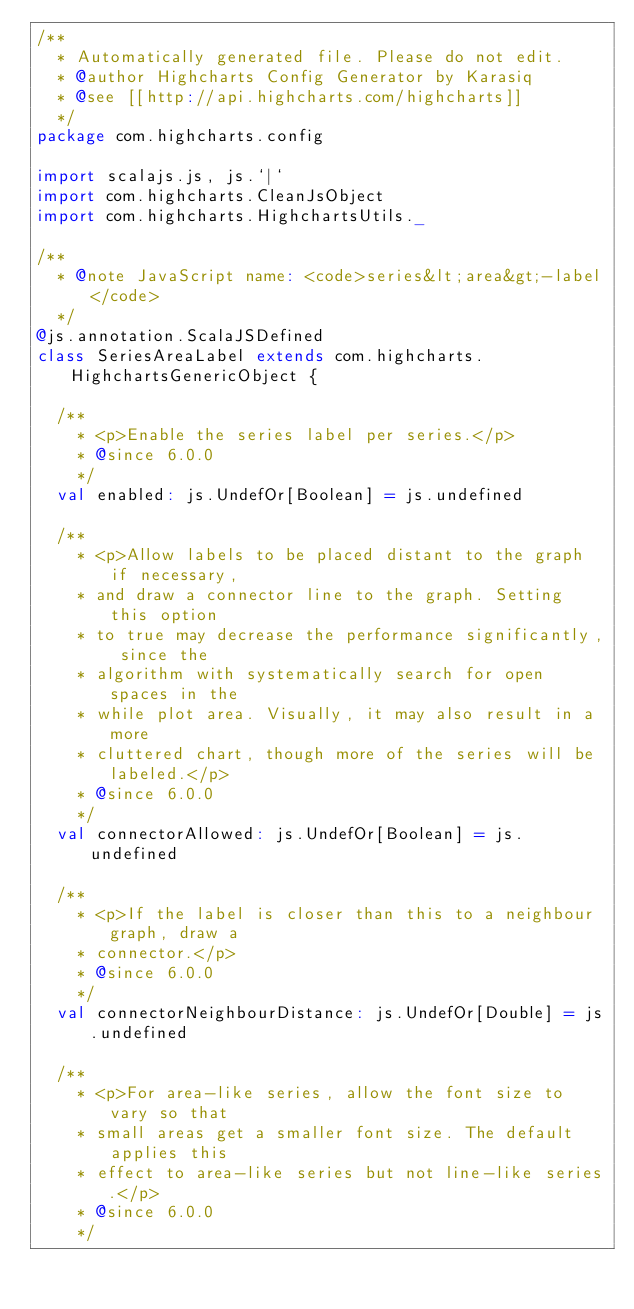Convert code to text. <code><loc_0><loc_0><loc_500><loc_500><_Scala_>/**
  * Automatically generated file. Please do not edit.
  * @author Highcharts Config Generator by Karasiq
  * @see [[http://api.highcharts.com/highcharts]]
  */
package com.highcharts.config

import scalajs.js, js.`|`
import com.highcharts.CleanJsObject
import com.highcharts.HighchartsUtils._

/**
  * @note JavaScript name: <code>series&lt;area&gt;-label</code>
  */
@js.annotation.ScalaJSDefined
class SeriesAreaLabel extends com.highcharts.HighchartsGenericObject {

  /**
    * <p>Enable the series label per series.</p>
    * @since 6.0.0
    */
  val enabled: js.UndefOr[Boolean] = js.undefined

  /**
    * <p>Allow labels to be placed distant to the graph if necessary,
    * and draw a connector line to the graph. Setting this option
    * to true may decrease the performance significantly, since the
    * algorithm with systematically search for open spaces in the
    * while plot area. Visually, it may also result in a more
    * cluttered chart, though more of the series will be labeled.</p>
    * @since 6.0.0
    */
  val connectorAllowed: js.UndefOr[Boolean] = js.undefined

  /**
    * <p>If the label is closer than this to a neighbour graph, draw a
    * connector.</p>
    * @since 6.0.0
    */
  val connectorNeighbourDistance: js.UndefOr[Double] = js.undefined

  /**
    * <p>For area-like series, allow the font size to vary so that
    * small areas get a smaller font size. The default applies this
    * effect to area-like series but not line-like series.</p>
    * @since 6.0.0
    */</code> 